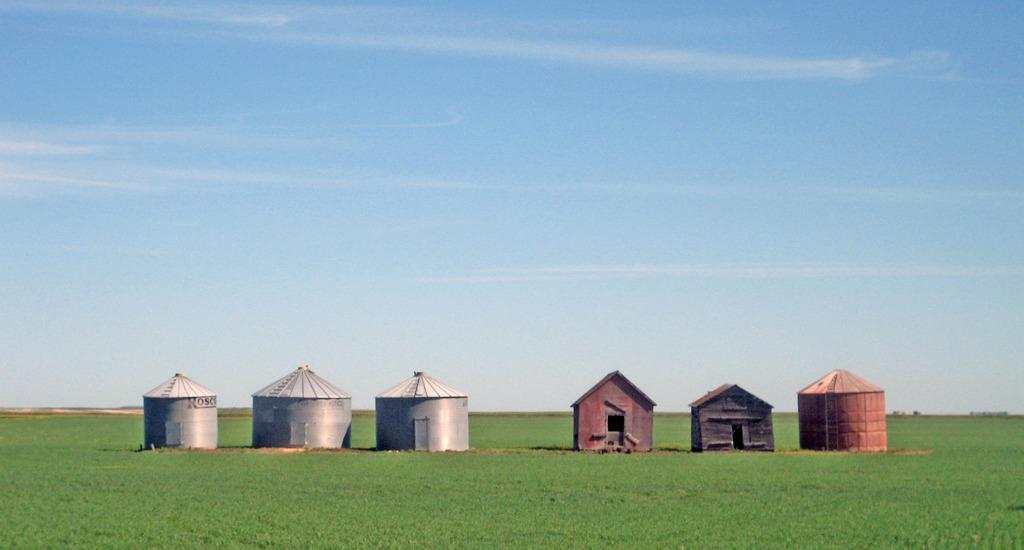How would you summarize this image in a sentence or two? In this image there are six huts on the grass, sky. 